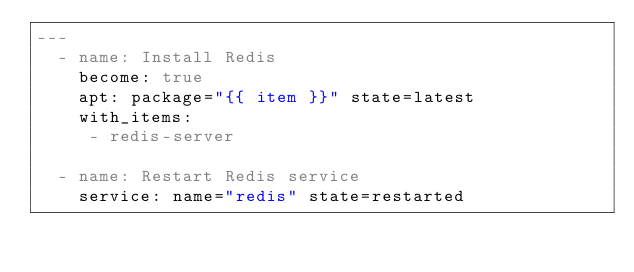<code> <loc_0><loc_0><loc_500><loc_500><_YAML_>---
  - name: Install Redis
    become: true
    apt: package="{{ item }}" state=latest
    with_items:
     - redis-server

  - name: Restart Redis service
    service: name="redis" state=restarted</code> 